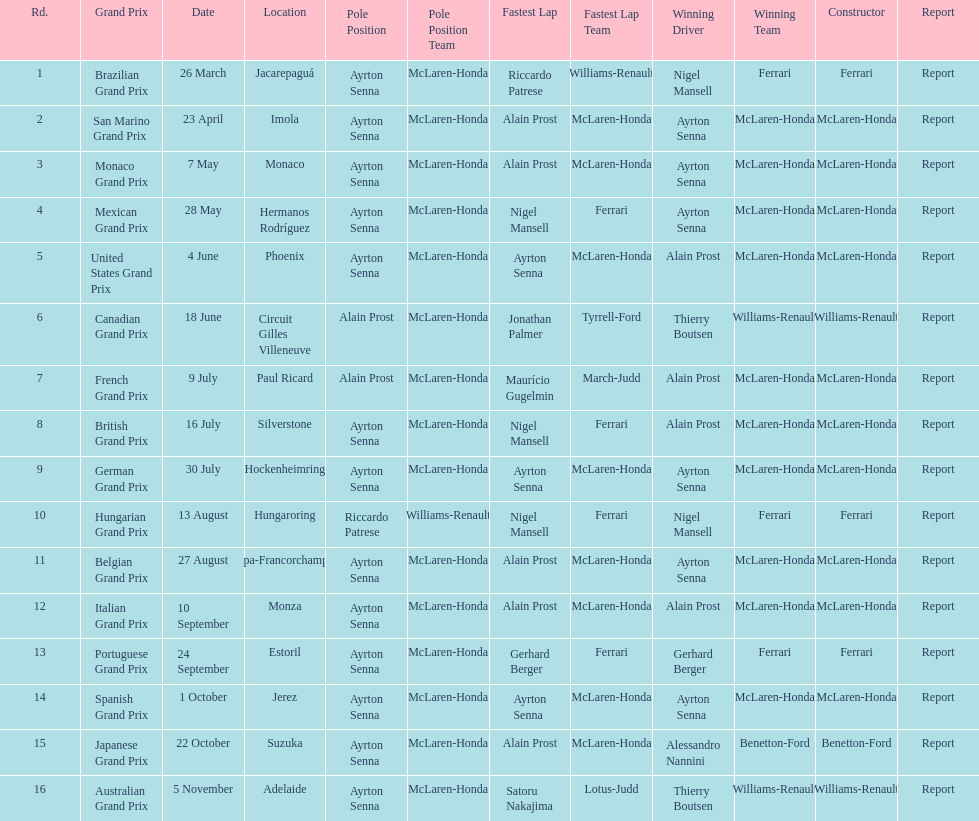Prost won the drivers title, who was his teammate? Ayrton Senna. 